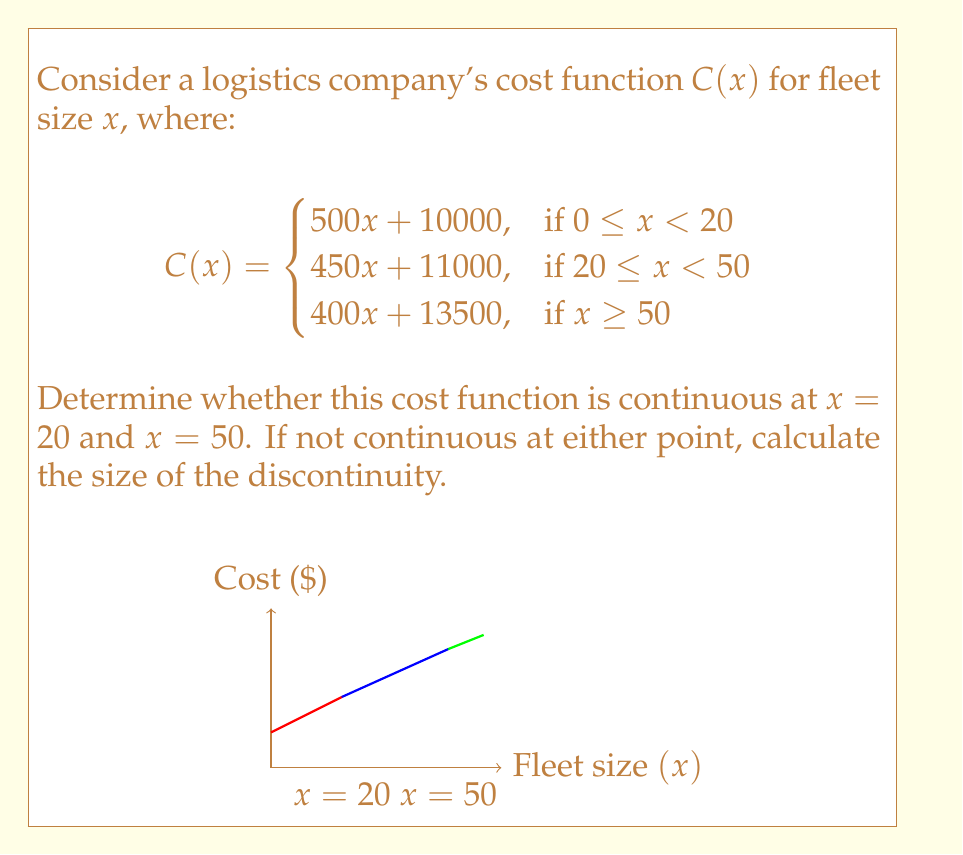Solve this math problem. To determine continuity, we need to check if the function is continuous at $x = 20$ and $x = 50$. A function is continuous at a point if the limit from both sides equals the function value at that point.

For $x = 20$:
1) Left limit: $\lim_{x \to 20^-} C(x) = 500(20) + 10000 = 20000$
2) Right limit: $\lim_{x \to 20^+} C(x) = 450(20) + 11000 = 20000$
3) Function value: $C(20) = 450(20) + 11000 = 20000$

All three values are equal, so the function is continuous at $x = 20$.

For $x = 50$:
1) Left limit: $\lim_{x \to 50^-} C(x) = 450(50) + 11000 = 33500$
2) Right limit: $\lim_{x \to 50^+} C(x) = 400(50) + 13500 = 33500$
3) Function value: $C(50) = 400(50) + 13500 = 33500$

All three values are equal, so the function is continuous at $x = 50$.

Therefore, the cost function $C(x)$ is continuous at both $x = 20$ and $x = 50$.
Answer: The cost function is continuous at both $x = 20$ and $x = 50$. 